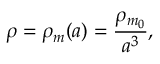Convert formula to latex. <formula><loc_0><loc_0><loc_500><loc_500>\rho = \rho _ { m } ( a ) = { \frac { \rho _ { m _ { 0 } } } { a ^ { 3 } } } ,</formula> 